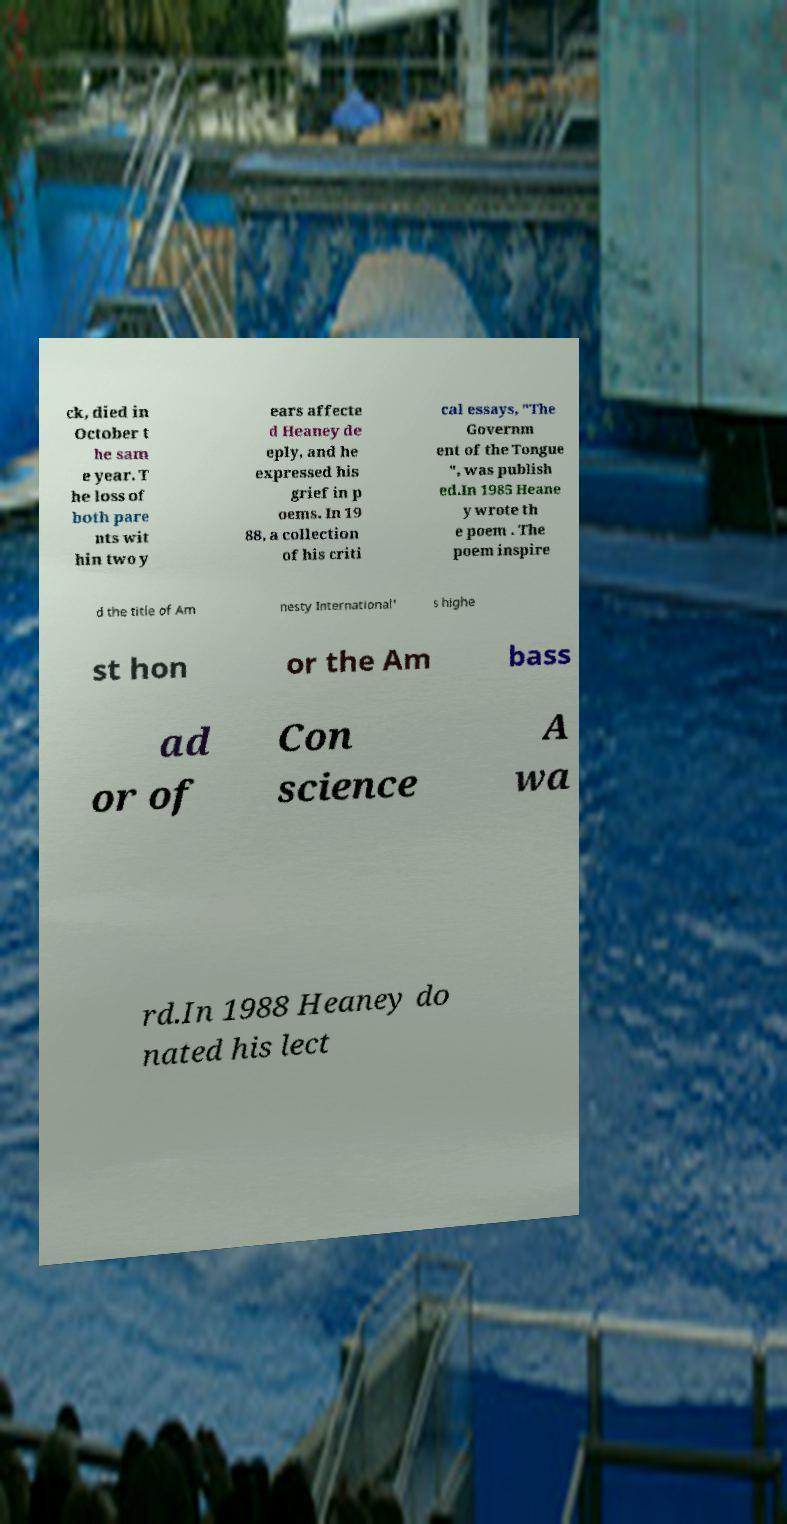Please read and relay the text visible in this image. What does it say? ck, died in October t he sam e year. T he loss of both pare nts wit hin two y ears affecte d Heaney de eply, and he expressed his grief in p oems. In 19 88, a collection of his criti cal essays, "The Governm ent of the Tongue ", was publish ed.In 1985 Heane y wrote th e poem . The poem inspire d the title of Am nesty International' s highe st hon or the Am bass ad or of Con science A wa rd.In 1988 Heaney do nated his lect 